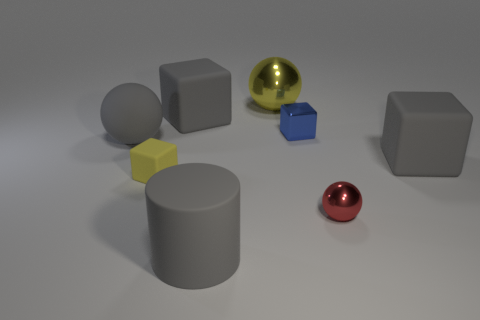There is a blue shiny object; what shape is it?
Ensure brevity in your answer.  Cube. How many things are right of the large rubber cylinder and left of the red thing?
Offer a very short reply. 2. Does the large metal object have the same color as the small rubber object?
Give a very brief answer. Yes. There is a gray thing that is the same shape as the small red thing; what is it made of?
Give a very brief answer. Rubber. Is there any other thing that has the same material as the gray cylinder?
Provide a short and direct response. Yes. Are there the same number of tiny rubber things in front of the yellow rubber block and things on the left side of the small red ball?
Your answer should be very brief. No. Are the big gray sphere and the red object made of the same material?
Provide a short and direct response. No. What number of brown objects are either tiny matte blocks or shiny objects?
Your answer should be compact. 0. How many large yellow objects are the same shape as the red metallic thing?
Ensure brevity in your answer.  1. What is the small ball made of?
Offer a terse response. Metal. 